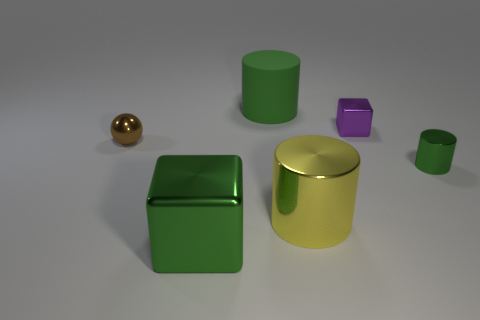Add 3 big blue cylinders. How many objects exist? 9 Subtract all balls. How many objects are left? 5 Add 1 big metal blocks. How many big metal blocks are left? 2 Add 5 purple metallic objects. How many purple metallic objects exist? 6 Subtract 1 purple cubes. How many objects are left? 5 Subtract all metallic things. Subtract all blue cylinders. How many objects are left? 1 